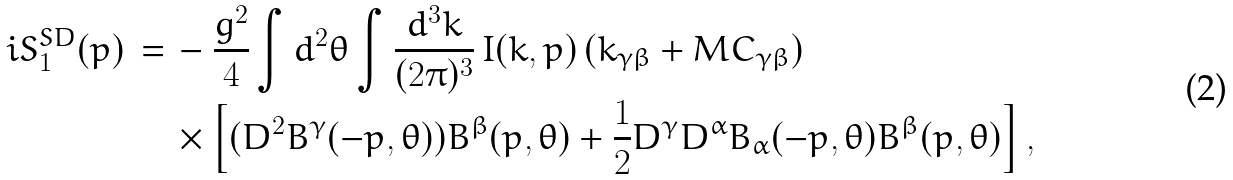<formula> <loc_0><loc_0><loc_500><loc_500>i S ^ { S D } _ { 1 } ( p ) \, = \, & - \frac { g ^ { 2 } } { 4 } \int d ^ { 2 } \theta \int \frac { d ^ { 3 } k } { ( 2 \pi ) ^ { 3 } } \, I ( k , p ) \, ( k _ { \gamma \beta } + M C _ { \gamma \beta } ) \\ & \times \left [ ( D ^ { 2 } B ^ { \gamma } ( - p , \theta ) ) B ^ { \beta } ( p , \theta ) + \frac { 1 } { 2 } D ^ { \gamma } D ^ { \alpha } B _ { \alpha } ( - p , \theta ) B ^ { \beta } ( p , \theta ) \right ] ,</formula> 